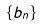<formula> <loc_0><loc_0><loc_500><loc_500>\{ b _ { n } \}</formula> 